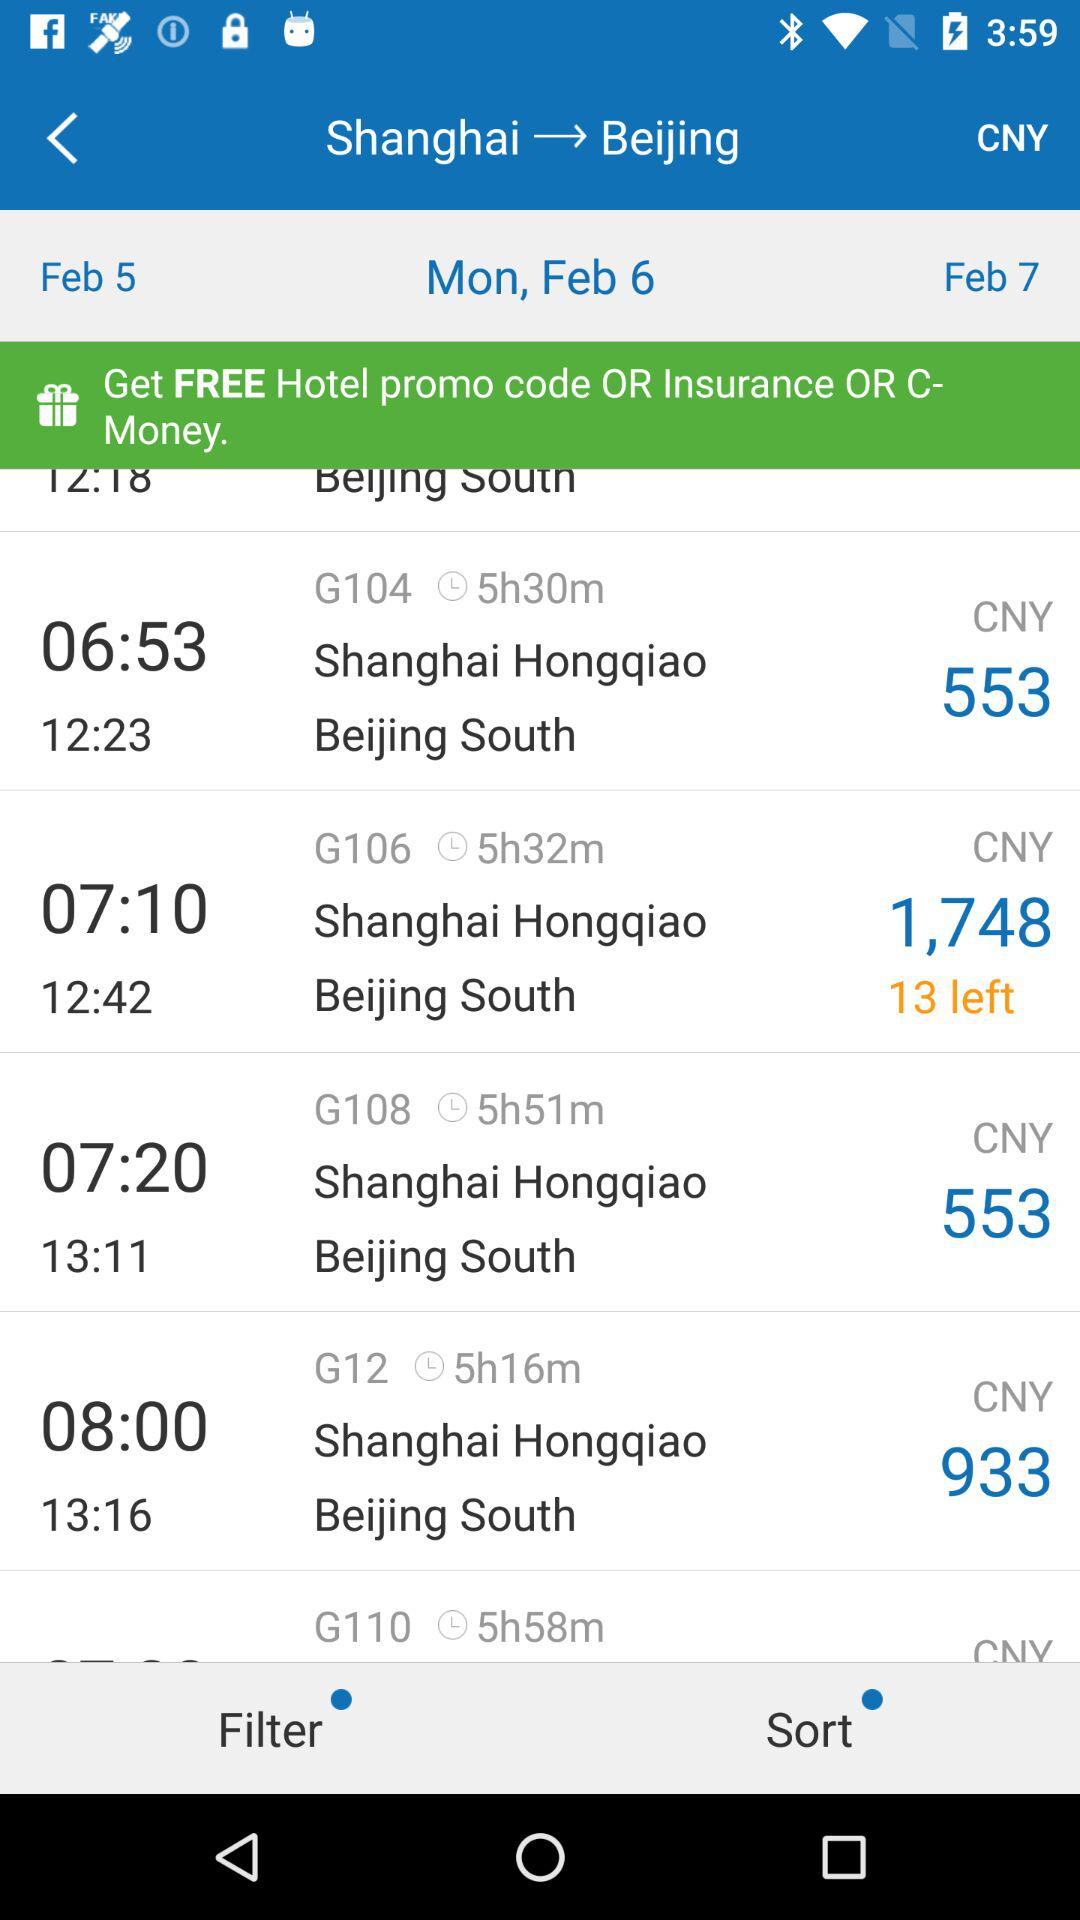How much more does the 1,748 CNY flight cost than the 933 CNY flight?
Answer the question using a single word or phrase. 815 